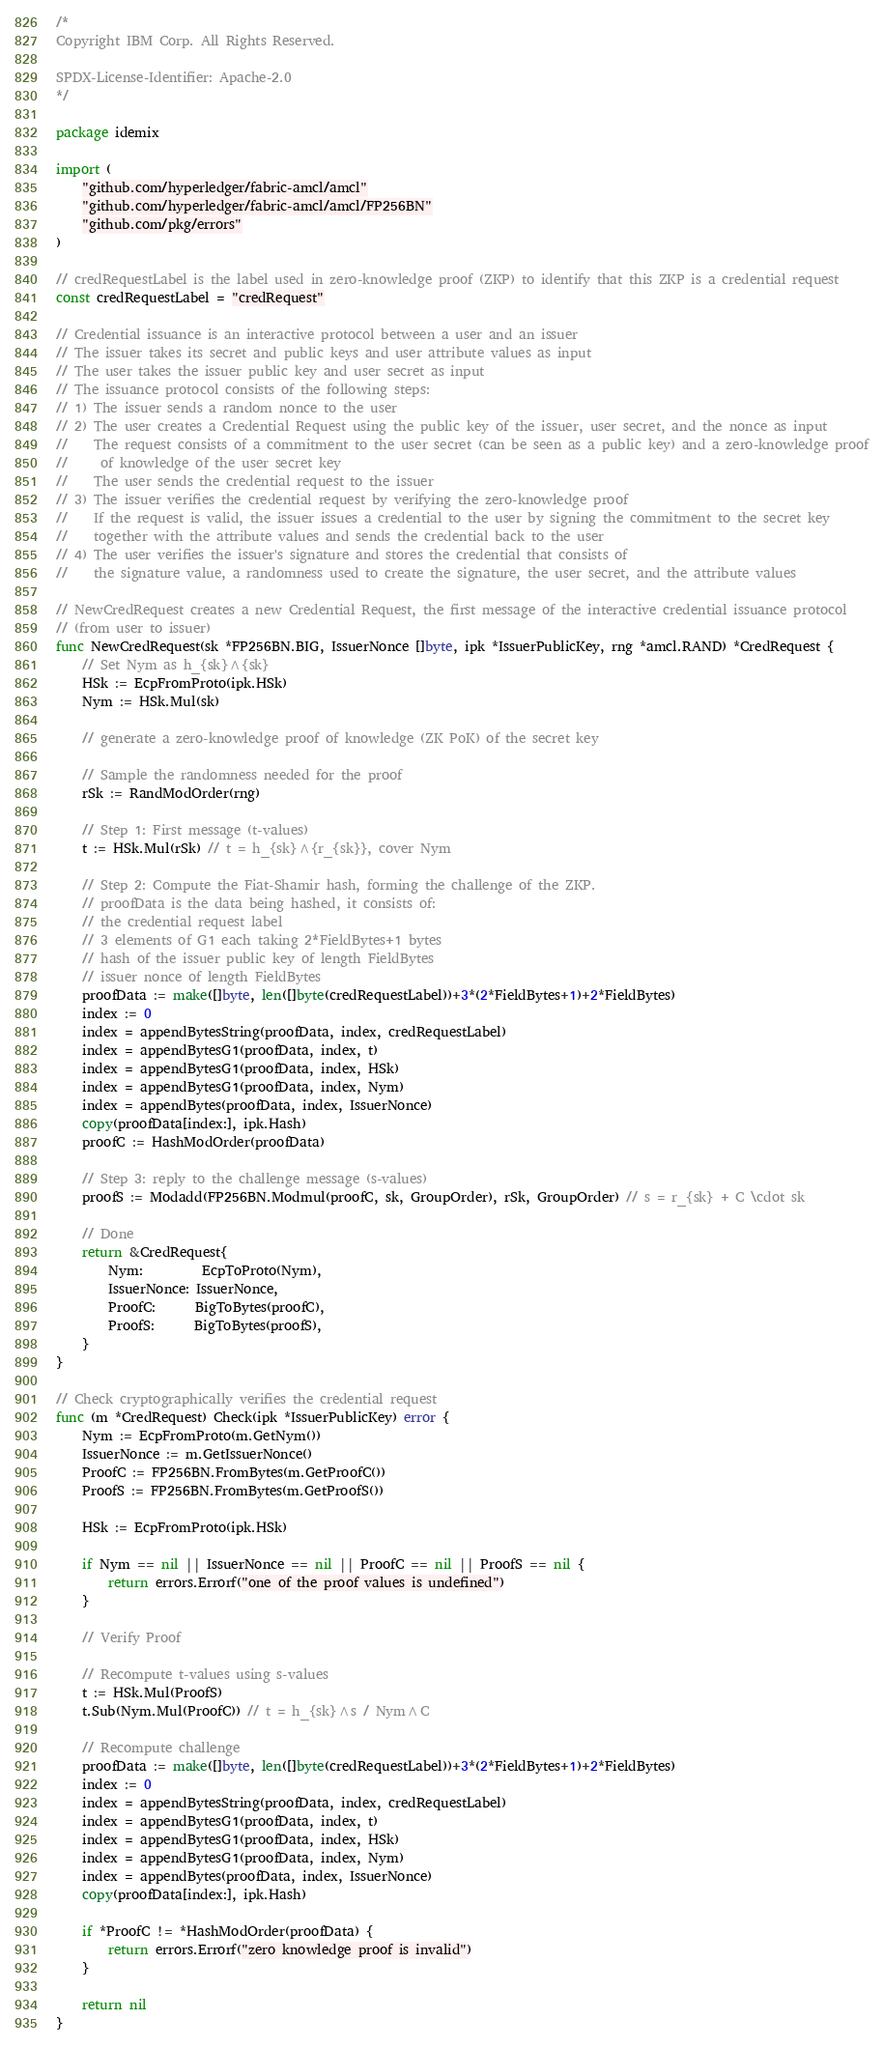<code> <loc_0><loc_0><loc_500><loc_500><_Go_>/*
Copyright IBM Corp. All Rights Reserved.

SPDX-License-Identifier: Apache-2.0
*/

package idemix

import (
	"github.com/hyperledger/fabric-amcl/amcl"
	"github.com/hyperledger/fabric-amcl/amcl/FP256BN"
	"github.com/pkg/errors"
)

// credRequestLabel is the label used in zero-knowledge proof (ZKP) to identify that this ZKP is a credential request
const credRequestLabel = "credRequest"

// Credential issuance is an interactive protocol between a user and an issuer
// The issuer takes its secret and public keys and user attribute values as input
// The user takes the issuer public key and user secret as input
// The issuance protocol consists of the following steps:
// 1) The issuer sends a random nonce to the user
// 2) The user creates a Credential Request using the public key of the issuer, user secret, and the nonce as input
//    The request consists of a commitment to the user secret (can be seen as a public key) and a zero-knowledge proof
//     of knowledge of the user secret key
//    The user sends the credential request to the issuer
// 3) The issuer verifies the credential request by verifying the zero-knowledge proof
//    If the request is valid, the issuer issues a credential to the user by signing the commitment to the secret key
//    together with the attribute values and sends the credential back to the user
// 4) The user verifies the issuer's signature and stores the credential that consists of
//    the signature value, a randomness used to create the signature, the user secret, and the attribute values

// NewCredRequest creates a new Credential Request, the first message of the interactive credential issuance protocol
// (from user to issuer)
func NewCredRequest(sk *FP256BN.BIG, IssuerNonce []byte, ipk *IssuerPublicKey, rng *amcl.RAND) *CredRequest {
	// Set Nym as h_{sk}^{sk}
	HSk := EcpFromProto(ipk.HSk)
	Nym := HSk.Mul(sk)

	// generate a zero-knowledge proof of knowledge (ZK PoK) of the secret key

	// Sample the randomness needed for the proof
	rSk := RandModOrder(rng)

	// Step 1: First message (t-values)
	t := HSk.Mul(rSk) // t = h_{sk}^{r_{sk}}, cover Nym

	// Step 2: Compute the Fiat-Shamir hash, forming the challenge of the ZKP.
	// proofData is the data being hashed, it consists of:
	// the credential request label
	// 3 elements of G1 each taking 2*FieldBytes+1 bytes
	// hash of the issuer public key of length FieldBytes
	// issuer nonce of length FieldBytes
	proofData := make([]byte, len([]byte(credRequestLabel))+3*(2*FieldBytes+1)+2*FieldBytes)
	index := 0
	index = appendBytesString(proofData, index, credRequestLabel)
	index = appendBytesG1(proofData, index, t)
	index = appendBytesG1(proofData, index, HSk)
	index = appendBytesG1(proofData, index, Nym)
	index = appendBytes(proofData, index, IssuerNonce)
	copy(proofData[index:], ipk.Hash)
	proofC := HashModOrder(proofData)

	// Step 3: reply to the challenge message (s-values)
	proofS := Modadd(FP256BN.Modmul(proofC, sk, GroupOrder), rSk, GroupOrder) // s = r_{sk} + C \cdot sk

	// Done
	return &CredRequest{
		Nym:         EcpToProto(Nym),
		IssuerNonce: IssuerNonce,
		ProofC:      BigToBytes(proofC),
		ProofS:      BigToBytes(proofS),
	}
}

// Check cryptographically verifies the credential request
func (m *CredRequest) Check(ipk *IssuerPublicKey) error {
	Nym := EcpFromProto(m.GetNym())
	IssuerNonce := m.GetIssuerNonce()
	ProofC := FP256BN.FromBytes(m.GetProofC())
	ProofS := FP256BN.FromBytes(m.GetProofS())

	HSk := EcpFromProto(ipk.HSk)

	if Nym == nil || IssuerNonce == nil || ProofC == nil || ProofS == nil {
		return errors.Errorf("one of the proof values is undefined")
	}

	// Verify Proof

	// Recompute t-values using s-values
	t := HSk.Mul(ProofS)
	t.Sub(Nym.Mul(ProofC)) // t = h_{sk}^s / Nym^C

	// Recompute challenge
	proofData := make([]byte, len([]byte(credRequestLabel))+3*(2*FieldBytes+1)+2*FieldBytes)
	index := 0
	index = appendBytesString(proofData, index, credRequestLabel)
	index = appendBytesG1(proofData, index, t)
	index = appendBytesG1(proofData, index, HSk)
	index = appendBytesG1(proofData, index, Nym)
	index = appendBytes(proofData, index, IssuerNonce)
	copy(proofData[index:], ipk.Hash)

	if *ProofC != *HashModOrder(proofData) {
		return errors.Errorf("zero knowledge proof is invalid")
	}

	return nil
}
</code> 